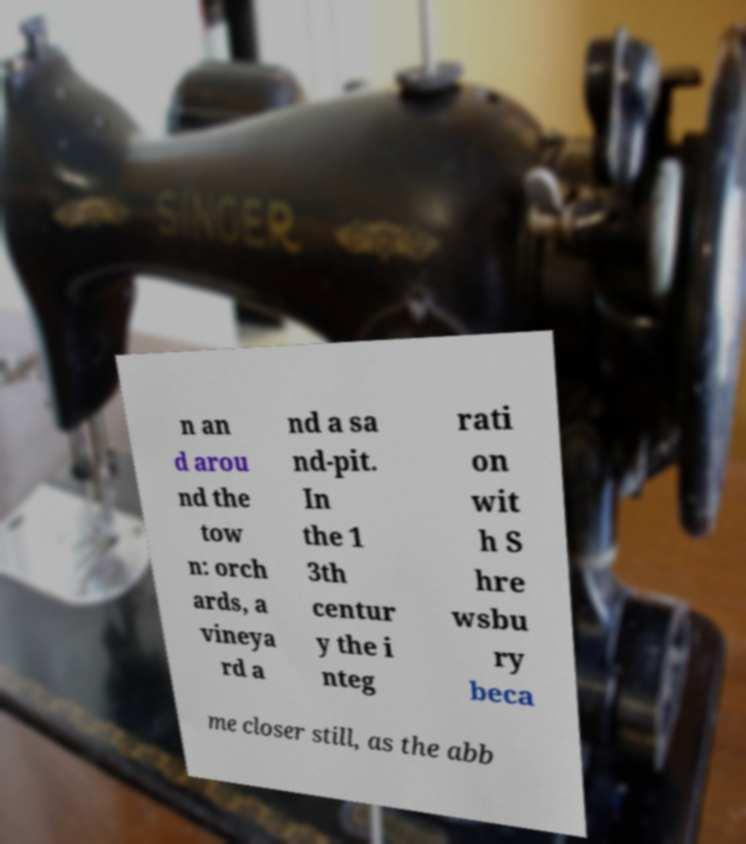Please read and relay the text visible in this image. What does it say? n an d arou nd the tow n: orch ards, a vineya rd a nd a sa nd-pit. In the 1 3th centur y the i nteg rati on wit h S hre wsbu ry beca me closer still, as the abb 